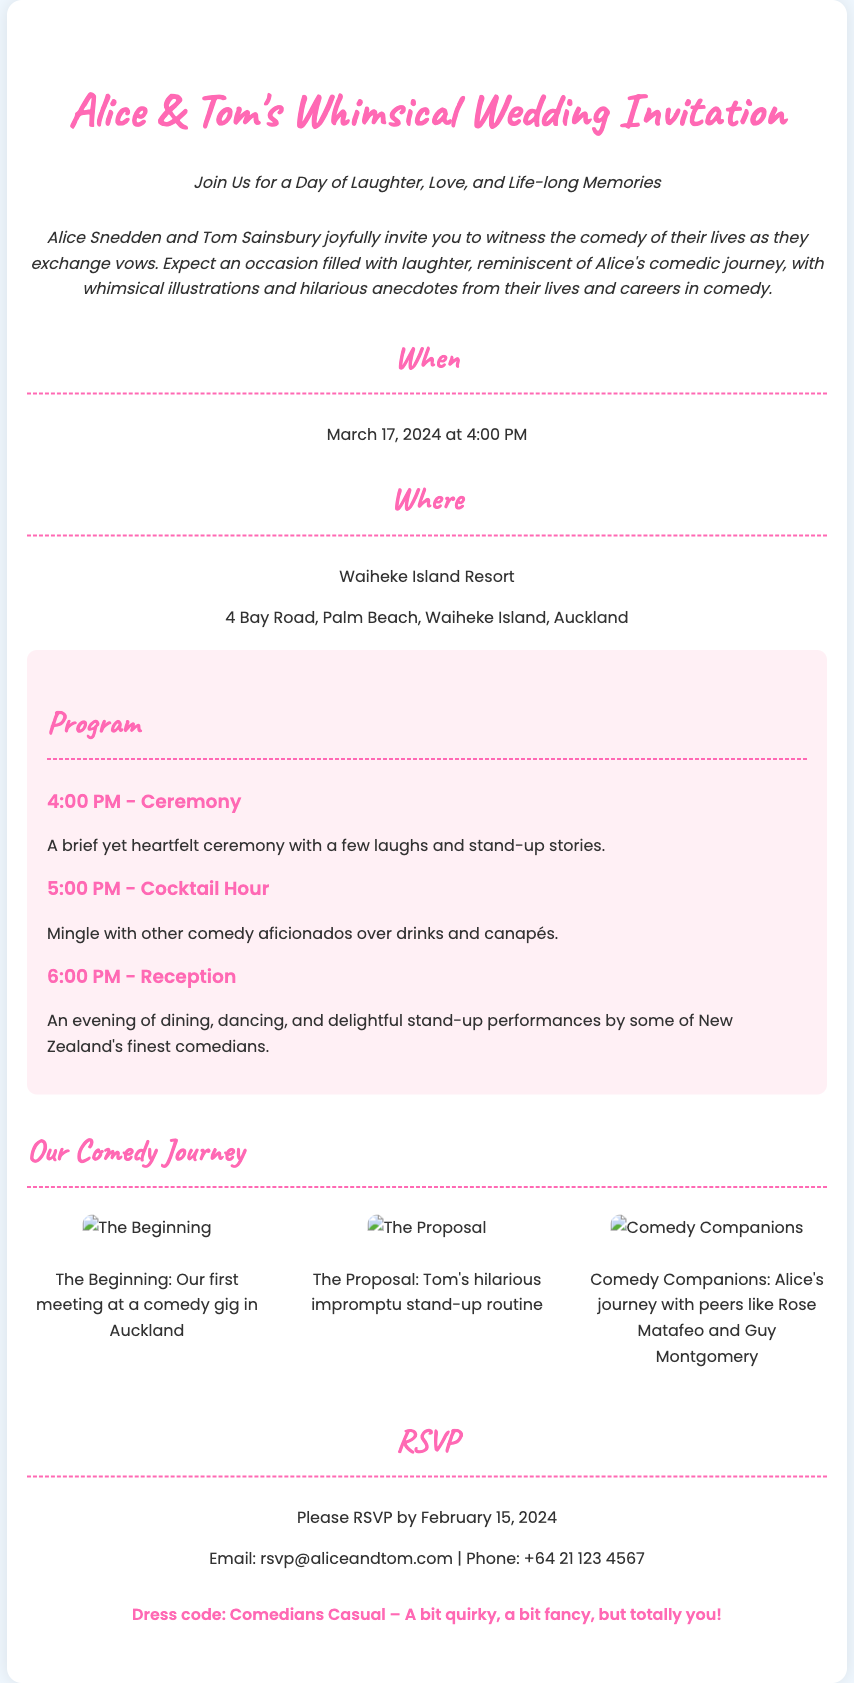What is the date of the wedding? The wedding date is provided in the date-time section of the document.
Answer: March 17, 2024 What is the venue of the wedding? The venue is mentioned in the venue section of the document.
Answer: Waiheke Island Resort Who are the couple getting married? The couple's names are listed at the beginning of the invitation.
Answer: Alice Snedden and Tom Sainsbury What time does the ceremony begin? The start time for the ceremony can be found in the program section.
Answer: 4:00 PM What is the dress code for the wedding? The dress code is specified in the note section of the document.
Answer: Comedians Casual What type of stories will be shared during the ceremony? The description about the ceremony includes details about the storytelling style.
Answer: Stand-up stories What is the RSVP deadline? The RSVP deadline is provided in the RSVP section of the document.
Answer: February 15, 2024 What will happen during the cocktail hour? The activities during the cocktail hour are outlined in the program section.
Answer: Mingle over drinks and canapés How did the couple meet? The meeting is illustrated in one of the sketches included in the invitation.
Answer: At a comedy gig in Auckland 